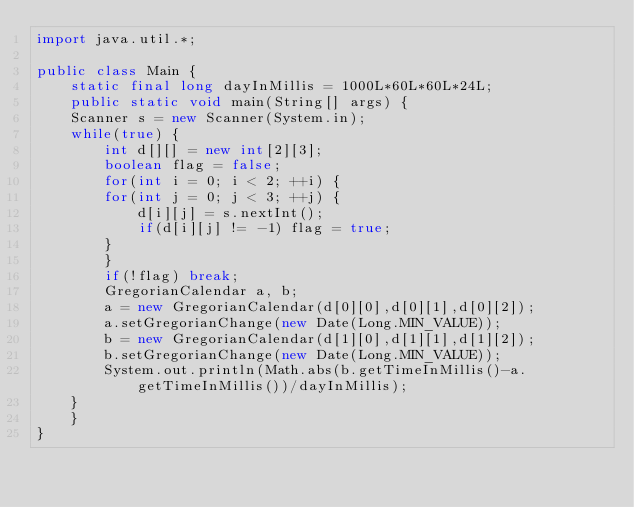<code> <loc_0><loc_0><loc_500><loc_500><_Java_>import java.util.*;

public class Main {
    static final long dayInMillis = 1000L*60L*60L*24L;
    public static void main(String[] args) {
	Scanner s = new Scanner(System.in);
	while(true) {
	    int d[][] = new int[2][3];
	    boolean flag = false;
	    for(int i = 0; i < 2; ++i) {
		for(int j = 0; j < 3; ++j) {
		    d[i][j] = s.nextInt();
		    if(d[i][j] != -1) flag = true;
		}
	    }
	    if(!flag) break;
	    GregorianCalendar a, b;
	    a = new GregorianCalendar(d[0][0],d[0][1],d[0][2]);
	    a.setGregorianChange(new Date(Long.MIN_VALUE));
	    b = new GregorianCalendar(d[1][0],d[1][1],d[1][2]);
	    b.setGregorianChange(new Date(Long.MIN_VALUE));
	    System.out.println(Math.abs(b.getTimeInMillis()-a.getTimeInMillis())/dayInMillis);
	}
    }
}</code> 